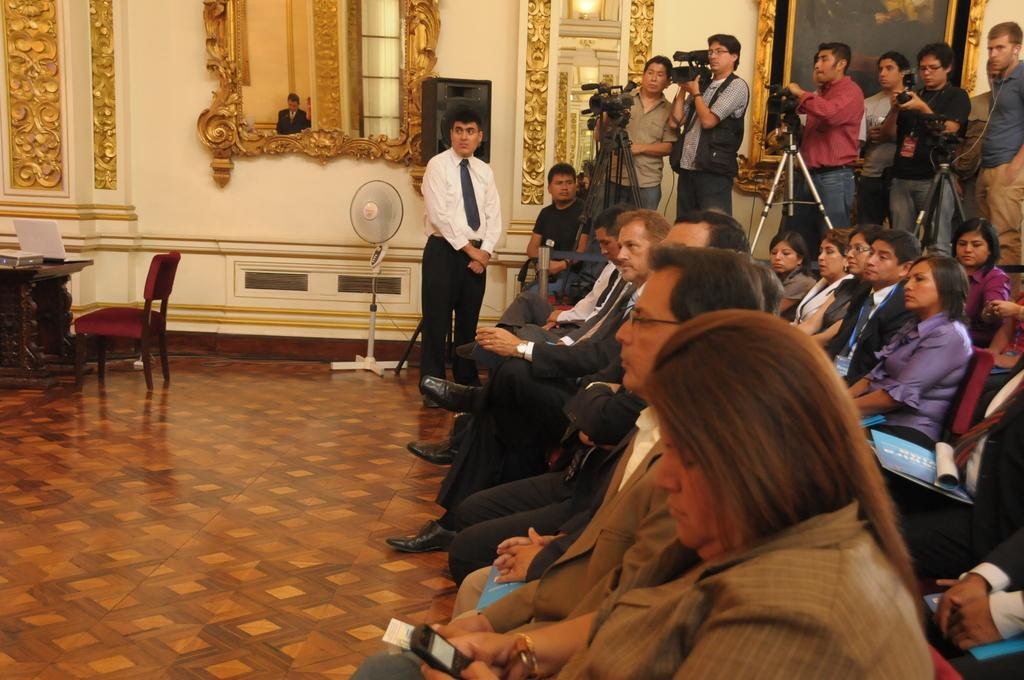How many people are in the image? There are people in the image, but the exact number is not specified. What are some of the people doing in the image? Some people are standing and holding cameras, while others are sitting on chairs. What objects can be seen in the image? There is a fan, a mirror, a chair, a table, and a laptop in the image. What type of metal is the doctor using to say good-bye in the image? There is no doctor or good-bye gesture in the image, and no mention of metal. 